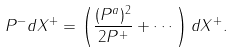<formula> <loc_0><loc_0><loc_500><loc_500>P ^ { - } d X ^ { + } = \left ( { \frac { ( P ^ { a } ) ^ { 2 } } { 2 P ^ { + } } } + \cdots \right ) d X ^ { + } .</formula> 